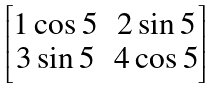Convert formula to latex. <formula><loc_0><loc_0><loc_500><loc_500>\begin{bmatrix} 1 \cos 5 & 2 \sin 5 \\ 3 \sin 5 & 4 \cos 5 \end{bmatrix}</formula> 